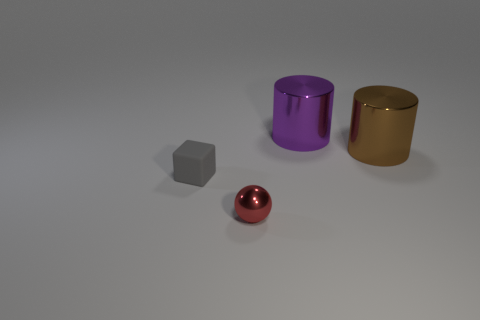What is the size of the brown thing?
Make the answer very short. Large. Are there any large purple shiny objects on the right side of the thing left of the shiny object that is in front of the small gray block?
Your response must be concise. Yes. Is the number of gray rubber things behind the ball greater than the number of big brown metal things that are behind the purple metallic thing?
Your answer should be very brief. Yes. What is the material of the red thing that is the same size as the gray matte block?
Provide a succinct answer. Metal. How many big things are metal objects or purple spheres?
Ensure brevity in your answer.  2. Is the big purple object the same shape as the brown thing?
Give a very brief answer. Yes. How many things are right of the purple metallic cylinder and to the left of the small metallic sphere?
Give a very brief answer. 0. The large purple thing that is made of the same material as the big brown cylinder is what shape?
Ensure brevity in your answer.  Cylinder. Is the size of the brown metallic cylinder the same as the purple cylinder?
Give a very brief answer. Yes. Is the material of the tiny red thing to the left of the big purple thing the same as the gray block?
Give a very brief answer. No. 